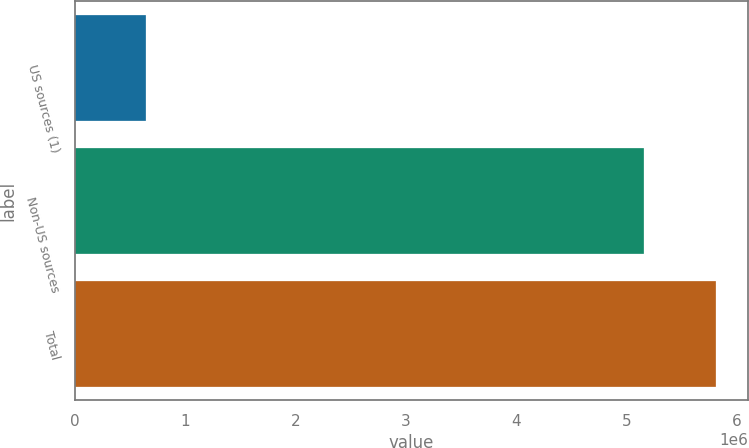<chart> <loc_0><loc_0><loc_500><loc_500><bar_chart><fcel>US sources (1)<fcel>Non-US sources<fcel>Total<nl><fcel>645943<fcel>5.16215e+06<fcel>5.80809e+06<nl></chart> 